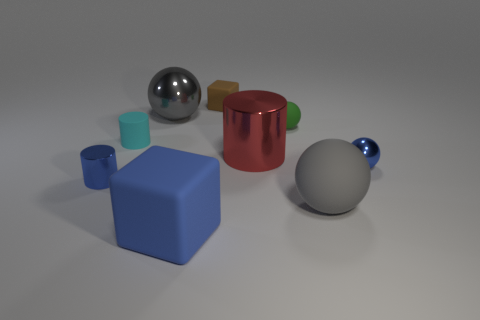Is the number of gray things that are in front of the big metal cylinder less than the number of green objects?
Your answer should be very brief. No. Is there a purple metallic cube that has the same size as the gray matte object?
Your answer should be compact. No. Do the tiny shiny sphere and the rubber cube in front of the tiny rubber cube have the same color?
Your response must be concise. Yes. What number of blue matte objects are behind the blue object that is on the left side of the large blue block?
Offer a terse response. 0. There is a small object that is to the right of the large gray ball that is on the right side of the large metal cylinder; what color is it?
Your answer should be compact. Blue. What is the small thing that is both to the right of the brown rubber block and in front of the small green sphere made of?
Your answer should be compact. Metal. Is there another small object that has the same shape as the brown thing?
Ensure brevity in your answer.  No. There is a metal thing right of the green thing; does it have the same shape as the tiny green rubber object?
Your answer should be very brief. Yes. How many spheres are both behind the gray matte object and right of the tiny green matte object?
Make the answer very short. 1. The blue matte thing that is left of the big red thing has what shape?
Offer a very short reply. Cube. 